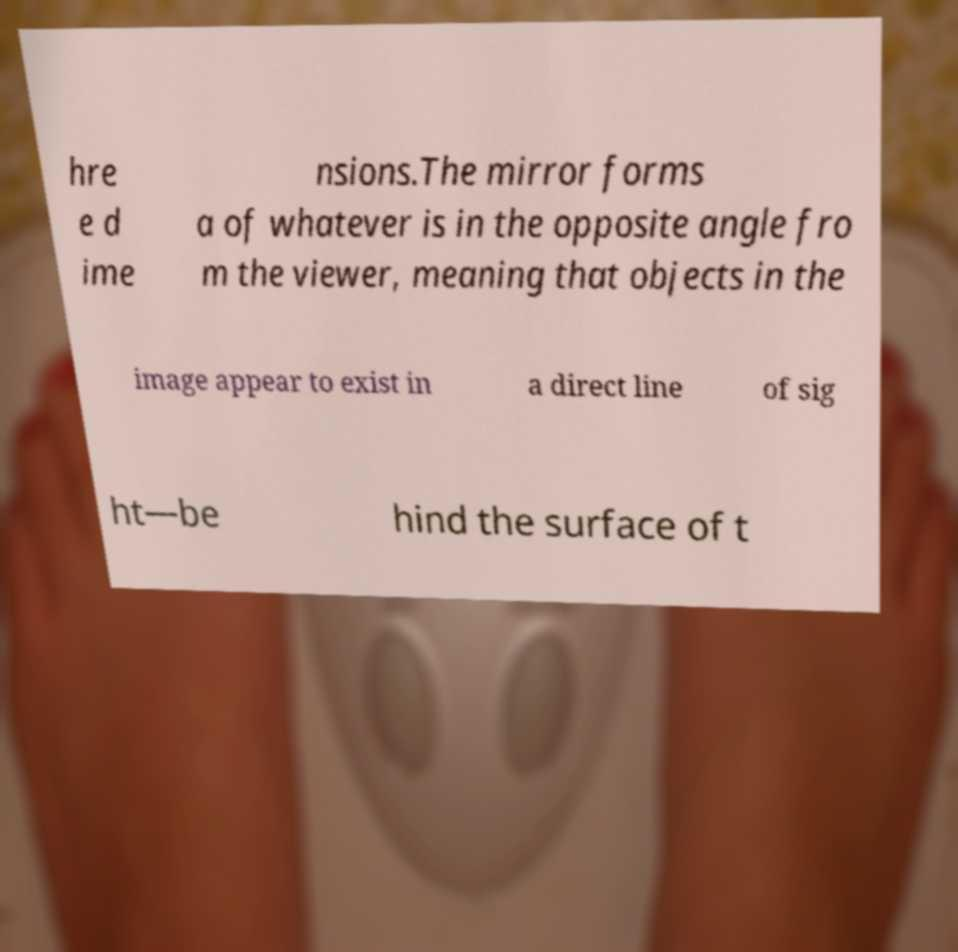For documentation purposes, I need the text within this image transcribed. Could you provide that? hre e d ime nsions.The mirror forms a of whatever is in the opposite angle fro m the viewer, meaning that objects in the image appear to exist in a direct line of sig ht—be hind the surface of t 